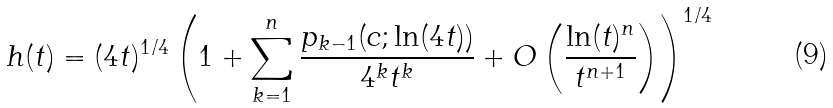Convert formula to latex. <formula><loc_0><loc_0><loc_500><loc_500>h ( t ) = ( 4 t ) ^ { 1 / 4 } \left ( 1 + \sum ^ { n } _ { k = 1 } \frac { p _ { k - 1 } ( c ; \ln ( 4 t ) ) } { 4 ^ { k } t ^ { k } } + O \left ( \frac { \ln ( t ) ^ { n } } { t ^ { n + 1 } } \right ) \right ) ^ { 1 / 4 }</formula> 